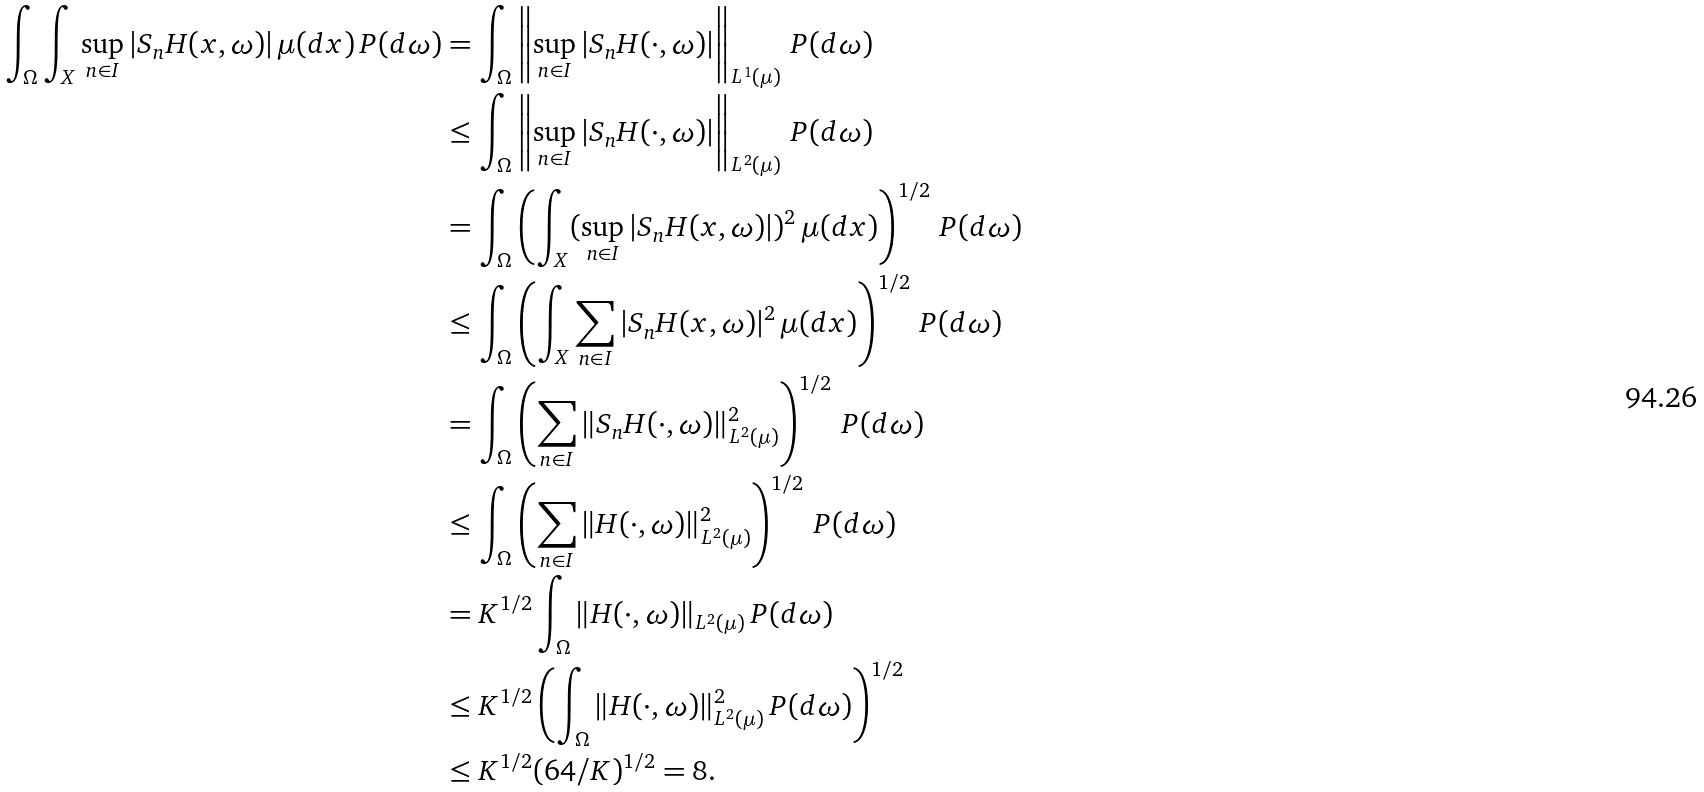<formula> <loc_0><loc_0><loc_500><loc_500>\int _ { \Omega } \int _ { X } \sup _ { n \in I } | S _ { n } H ( x , \omega ) | \, \mu ( d x ) \, P ( d \omega ) & = \int _ { \Omega } \left \| \sup _ { n \in I } | S _ { n } H ( \cdot , \omega ) | \right \| _ { L ^ { 1 } ( \mu ) } \, P ( d \omega ) \\ & \leq \int _ { \Omega } \left \| \sup _ { n \in I } | S _ { n } H ( \cdot , \omega ) | \right \| _ { L ^ { 2 } ( \mu ) } \, P ( d \omega ) \\ & = \int _ { \Omega } \left ( \int _ { X } ( \sup _ { n \in I } | S _ { n } H ( x , \omega ) | ) ^ { 2 } \, \mu ( d x ) \right ) ^ { 1 / 2 } \, P ( d \omega ) \\ & \leq \int _ { \Omega } \left ( \int _ { X } \sum _ { n \in I } | S _ { n } H ( x , \omega ) | ^ { 2 } \, \mu ( d x ) \right ) ^ { 1 / 2 } \, P ( d \omega ) \\ & = \int _ { \Omega } \left ( \sum _ { n \in I } \| S _ { n } H ( \cdot , \omega ) \| _ { L ^ { 2 } ( \mu ) } ^ { 2 } \right ) ^ { 1 / 2 } \, P ( d \omega ) \\ & \leq \int _ { \Omega } \left ( \sum _ { n \in I } \| H ( \cdot , \omega ) \| _ { L ^ { 2 } ( \mu ) } ^ { 2 } \right ) ^ { 1 / 2 } \, P ( d \omega ) \\ & = K ^ { 1 / 2 } \int _ { \Omega } \| H ( \cdot , \omega ) \| _ { L ^ { 2 } ( \mu ) } \, P ( d \omega ) \\ & \leq K ^ { 1 / 2 } \left ( \int _ { \Omega } \| H ( \cdot , \omega ) \| _ { L ^ { 2 } ( \mu ) } ^ { 2 } \, P ( d \omega ) \right ) ^ { 1 / 2 } \\ & \leq K ^ { 1 / 2 } ( 6 4 / K ) ^ { 1 / 2 } = 8 .</formula> 